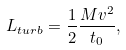Convert formula to latex. <formula><loc_0><loc_0><loc_500><loc_500>L _ { t u r b } = \frac { 1 } { 2 } \frac { M v ^ { 2 } } { t _ { 0 } } ,</formula> 